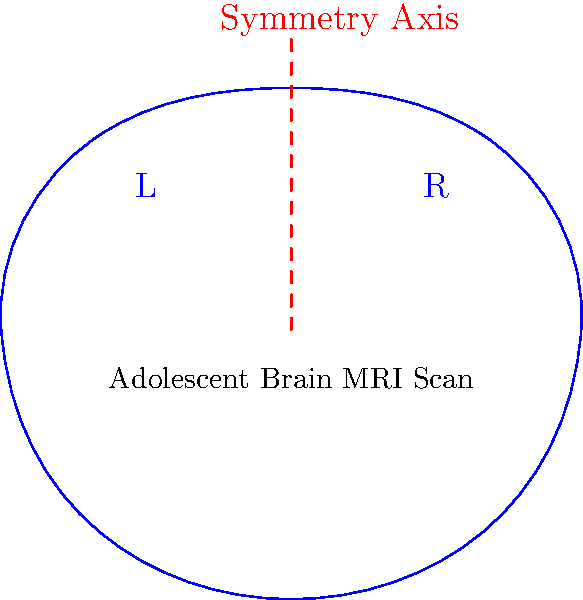In the MRI scan of an adolescent brain shown above, which group theory concept best describes the relationship between the left (L) and right (R) hemispheres, and how might deviations from this concept indicate potential developmental issues? To answer this question, let's break it down step-by-step:

1. Group Theory Concept:
   The image shows a clear line of symmetry dividing the brain into left and right hemispheres. This symmetry is best described by the group theory concept of "reflection symmetry" or "mirror symmetry."

2. Mathematical Representation:
   In group theory, this symmetry can be represented by the cyclic group $C_2$, which has order 2. The symmetry operation can be described as:
   $$f: (x, y) \rightarrow (-x, y)$$
   where the y-axis (in this case, the red dashed line) is the axis of symmetry.

3. Biological Significance:
   In healthy adolescent brain development, there is generally a high degree of symmetry between the left and right hemispheres. This symmetry is crucial for various cognitive functions and motor skills.

4. Developmental Implications:
   Deviations from this symmetry might indicate:
   a) Asymmetric brain development, which could be associated with neurodevelopmental disorders like autism or ADHD.
   b) Localized abnormalities, such as tumors or lesions, which could disrupt the natural symmetry.
   c) Functional specialization differences, which might be related to language development or handedness.

5. Clinical Relevance:
   As a child psychiatrist, observing significant asymmetries in adolescent brain MRIs could prompt further investigation into:
   - Potential cognitive or behavioral issues
   - Neurological conditions
   - Developmental delays or atypical brain maturation processes

6. Limitations:
   It's important to note that some degree of asymmetry is normal and even necessary for certain brain functions. The key is identifying when asymmetry falls outside the normal range for adolescent development.
Answer: Reflection symmetry ($C_2$ group); deviations may indicate developmental issues. 